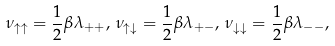Convert formula to latex. <formula><loc_0><loc_0><loc_500><loc_500>\nu _ { \uparrow \uparrow } = \frac { 1 } { 2 } \beta \lambda _ { + + } , \, \nu _ { \uparrow \downarrow } = \frac { 1 } { 2 } \beta \lambda _ { + - } , \, \nu _ { \downarrow \downarrow } = \frac { 1 } { 2 } \beta \lambda _ { - - } ,</formula> 